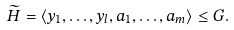<formula> <loc_0><loc_0><loc_500><loc_500>\widetilde { H } = \langle y _ { 1 } , \dots , y _ { l } , a _ { 1 } , \dots , a _ { m } \rangle \leq G .</formula> 